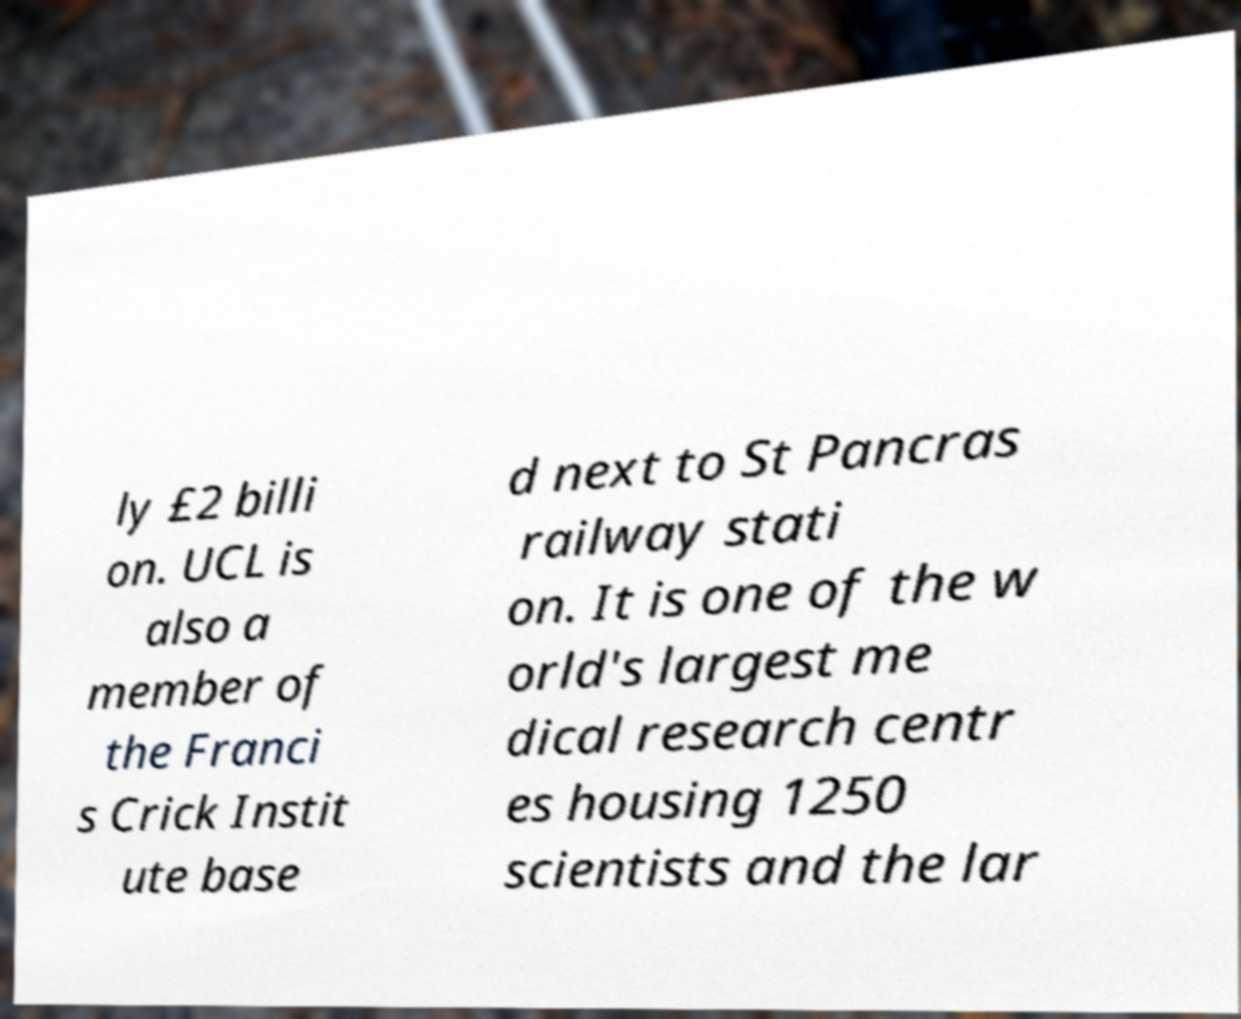What messages or text are displayed in this image? I need them in a readable, typed format. ly £2 billi on. UCL is also a member of the Franci s Crick Instit ute base d next to St Pancras railway stati on. It is one of the w orld's largest me dical research centr es housing 1250 scientists and the lar 